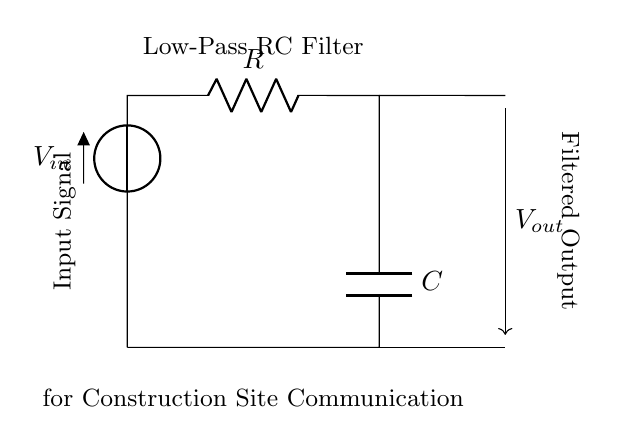What components are included in this circuit? The circuit consists of a resistor (R), a capacitor (C), and a voltage source (V).
Answer: resistor, capacitor, voltage source What type of filter is represented in the diagram? The circuit is a low-pass filter, which allows low-frequency signals to pass while attenuating high-frequency signals.
Answer: low-pass filter What is the output of this circuit? The output signal is taken across the capacitor and is termed as Vout, which will be the filtered version of Vin.
Answer: Vout How is the input signal connected in the circuit? The input signal is connected to the voltage source (Vin) at the top of the circuit, entering through the resistor and leading to the capacitor.
Answer: connected to voltage source What happens to high-frequency signals in this circuit? High-frequency signals are attenuated or reduced in amplitude as they pass through the circuit due to the properties of the resistor and capacitor.
Answer: attenuated What is the purpose of this RC filter in construction site communication devices? The purpose is to reduce electrical noise, allowing for clearer and more reliable communication in noisy environments typical of construction sites.
Answer: noise reduction 